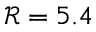Convert formula to latex. <formula><loc_0><loc_0><loc_500><loc_500>\mathcal { R } = 5 . 4</formula> 